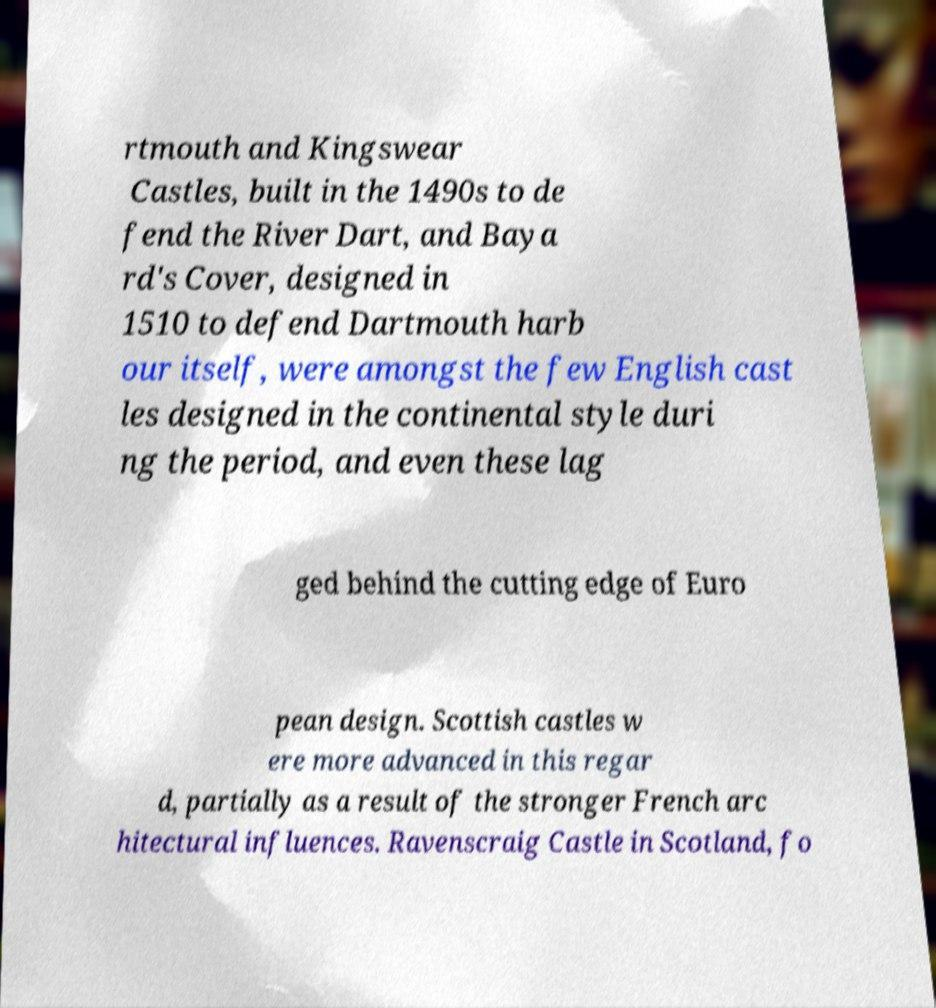Can you accurately transcribe the text from the provided image for me? rtmouth and Kingswear Castles, built in the 1490s to de fend the River Dart, and Baya rd's Cover, designed in 1510 to defend Dartmouth harb our itself, were amongst the few English cast les designed in the continental style duri ng the period, and even these lag ged behind the cutting edge of Euro pean design. Scottish castles w ere more advanced in this regar d, partially as a result of the stronger French arc hitectural influences. Ravenscraig Castle in Scotland, fo 